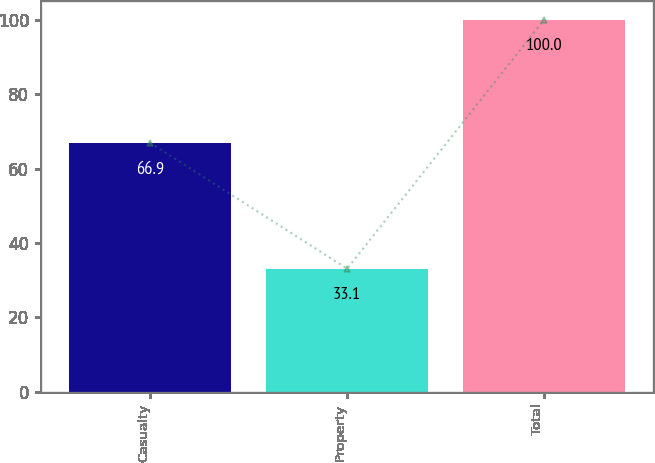Convert chart to OTSL. <chart><loc_0><loc_0><loc_500><loc_500><bar_chart><fcel>Casualty<fcel>Property<fcel>Total<nl><fcel>66.9<fcel>33.1<fcel>100<nl></chart> 